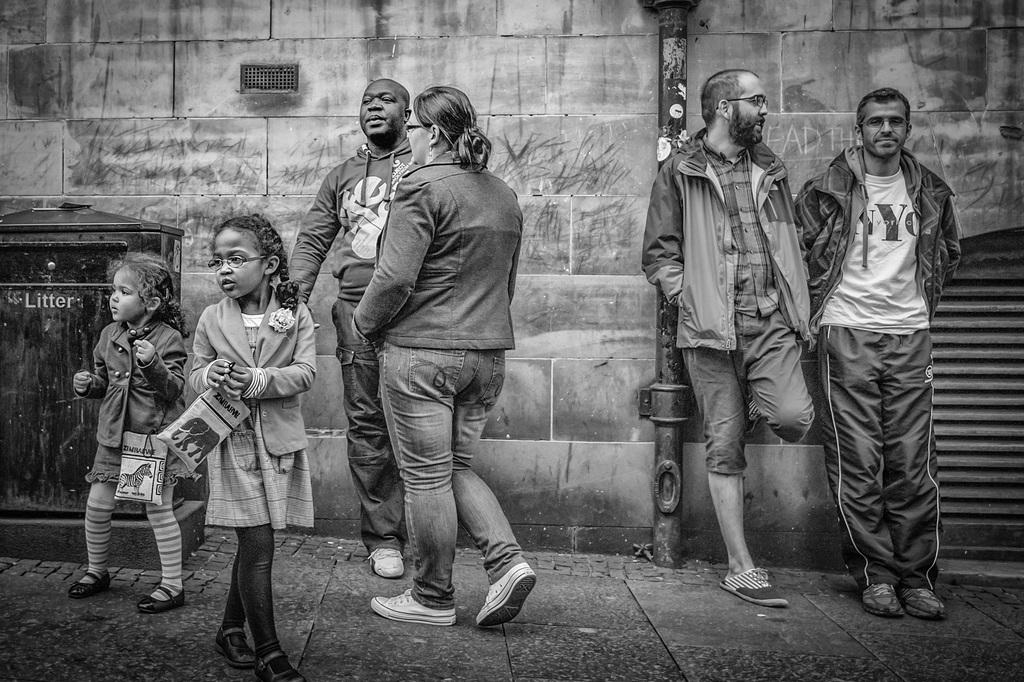What are the people in the image doing? The people in the image are standing and walking. What is the color scheme of the image? The image is in black and white. What can be seen on the ground in the image? There is a path in the image. What is the tall, vertical object in the image? There is a pole in the image. What is placed on a rock structure in the image? There is a box placed on a rock structure in the image. What is the flat, solid structure in the image? There is a wall in the image. Where is the robin sitting in the image? There is no robin present in the image. What type of seat can be seen in the image? There is no seat present in the image. 